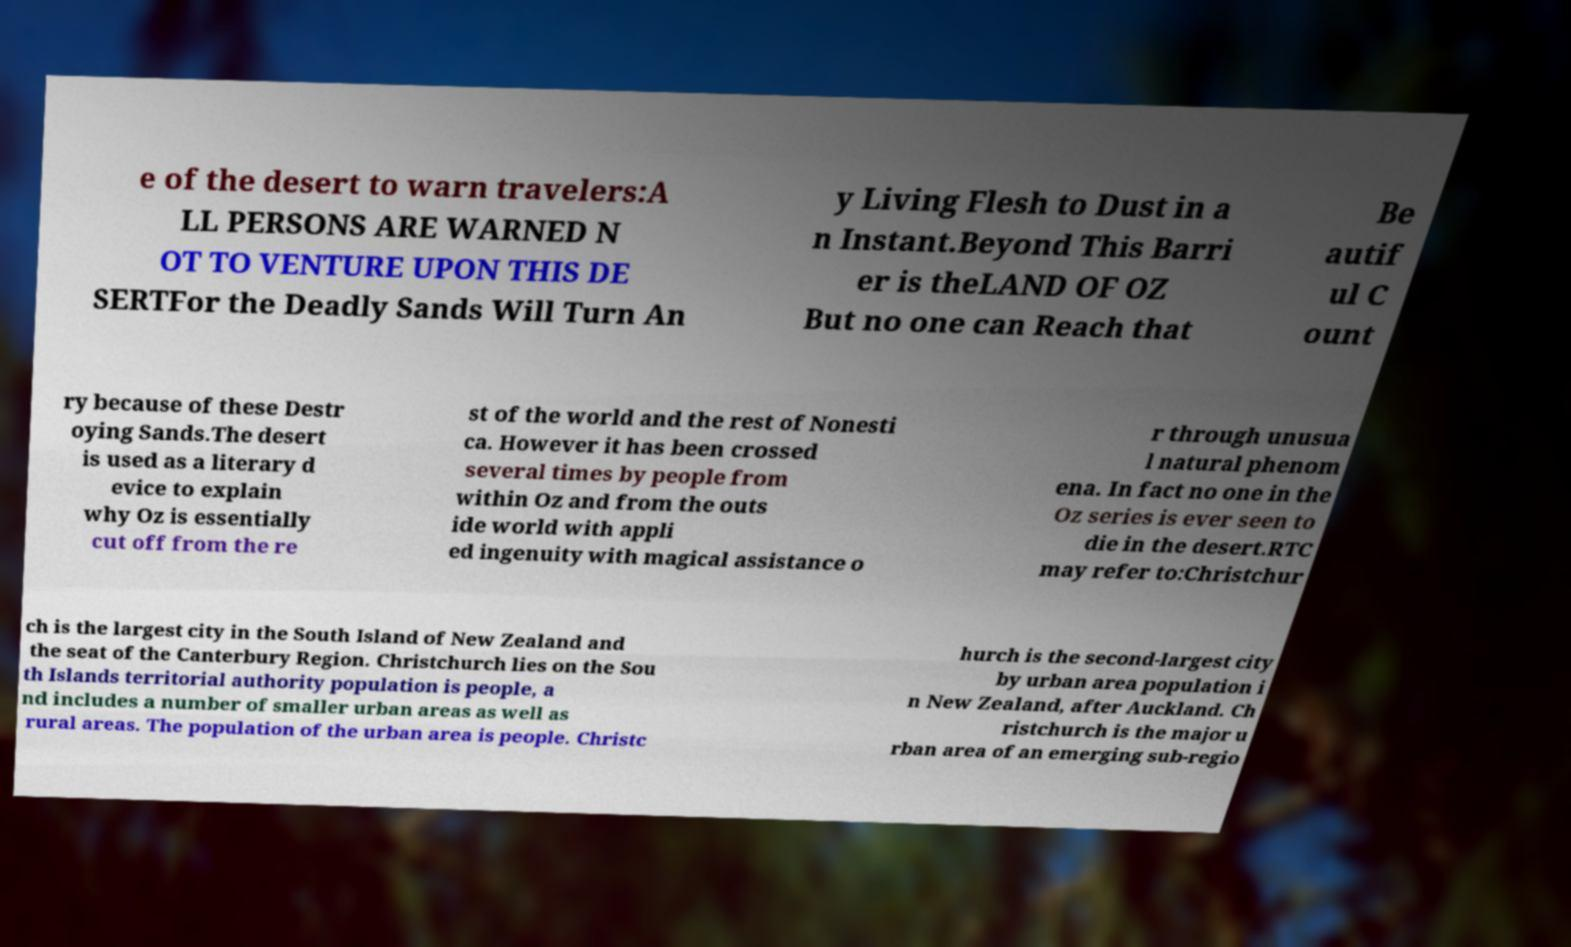I need the written content from this picture converted into text. Can you do that? e of the desert to warn travelers:A LL PERSONS ARE WARNED N OT TO VENTURE UPON THIS DE SERTFor the Deadly Sands Will Turn An y Living Flesh to Dust in a n Instant.Beyond This Barri er is theLAND OF OZ But no one can Reach that Be autif ul C ount ry because of these Destr oying Sands.The desert is used as a literary d evice to explain why Oz is essentially cut off from the re st of the world and the rest of Nonesti ca. However it has been crossed several times by people from within Oz and from the outs ide world with appli ed ingenuity with magical assistance o r through unusua l natural phenom ena. In fact no one in the Oz series is ever seen to die in the desert.RTC may refer to:Christchur ch is the largest city in the South Island of New Zealand and the seat of the Canterbury Region. Christchurch lies on the Sou th Islands territorial authority population is people, a nd includes a number of smaller urban areas as well as rural areas. The population of the urban area is people. Christc hurch is the second-largest city by urban area population i n New Zealand, after Auckland. Ch ristchurch is the major u rban area of an emerging sub-regio 